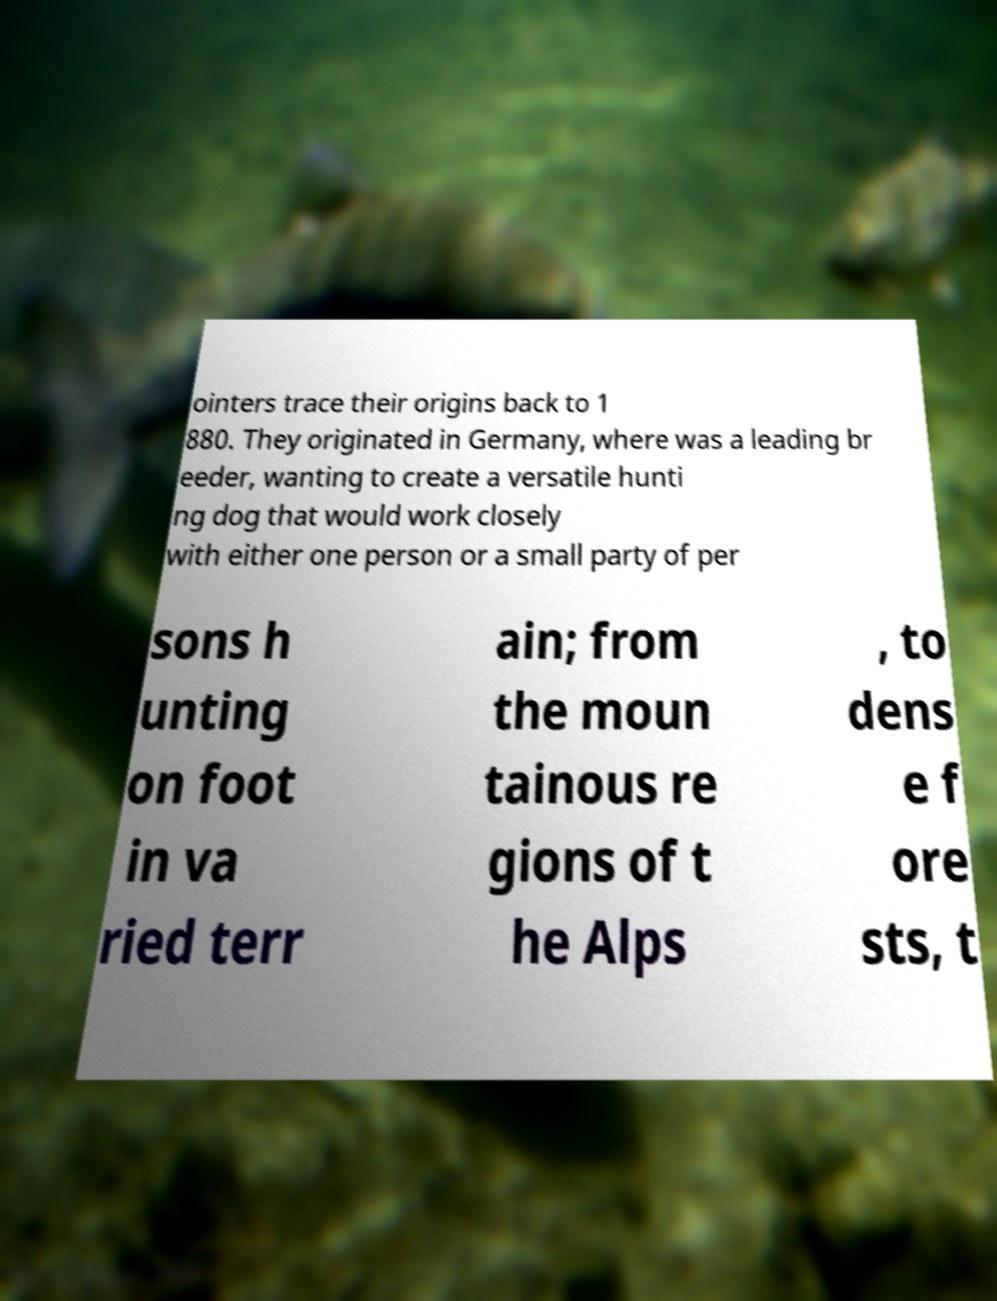Please read and relay the text visible in this image. What does it say? ointers trace their origins back to 1 880. They originated in Germany, where was a leading br eeder, wanting to create a versatile hunti ng dog that would work closely with either one person or a small party of per sons h unting on foot in va ried terr ain; from the moun tainous re gions of t he Alps , to dens e f ore sts, t 